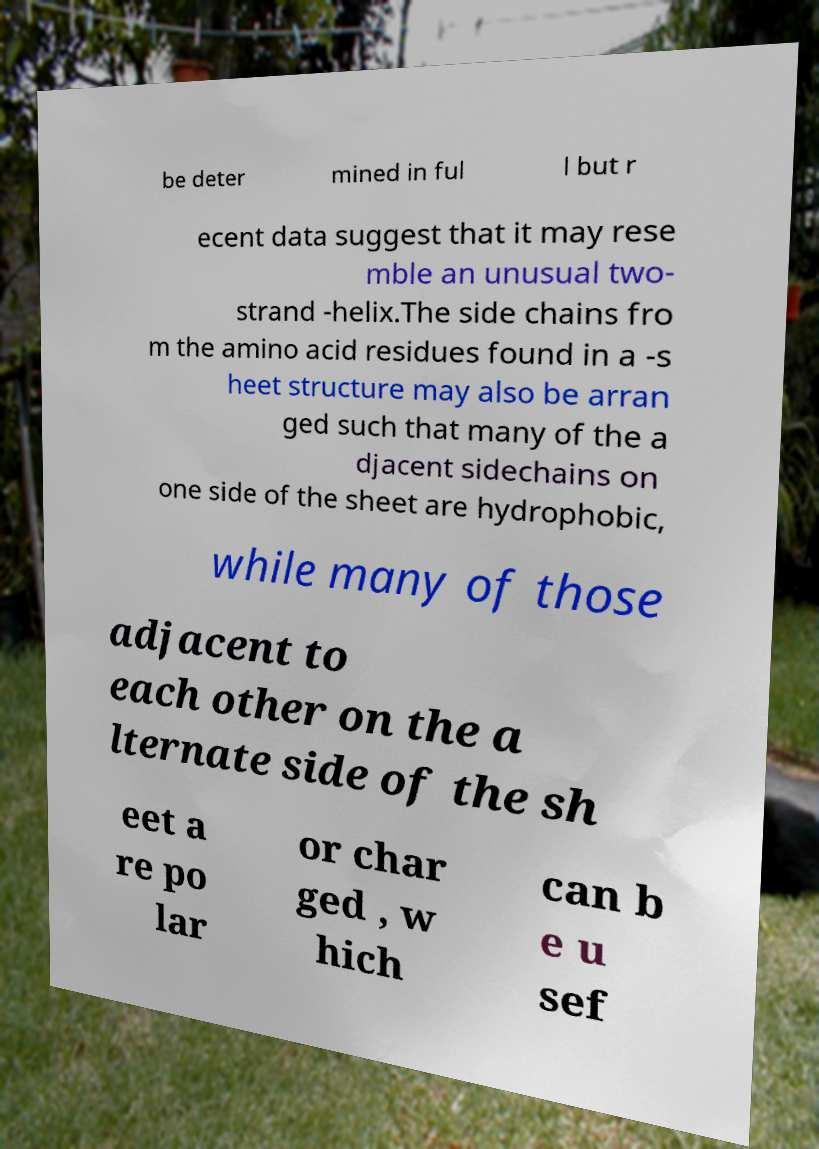Please identify and transcribe the text found in this image. be deter mined in ful l but r ecent data suggest that it may rese mble an unusual two- strand -helix.The side chains fro m the amino acid residues found in a -s heet structure may also be arran ged such that many of the a djacent sidechains on one side of the sheet are hydrophobic, while many of those adjacent to each other on the a lternate side of the sh eet a re po lar or char ged , w hich can b e u sef 